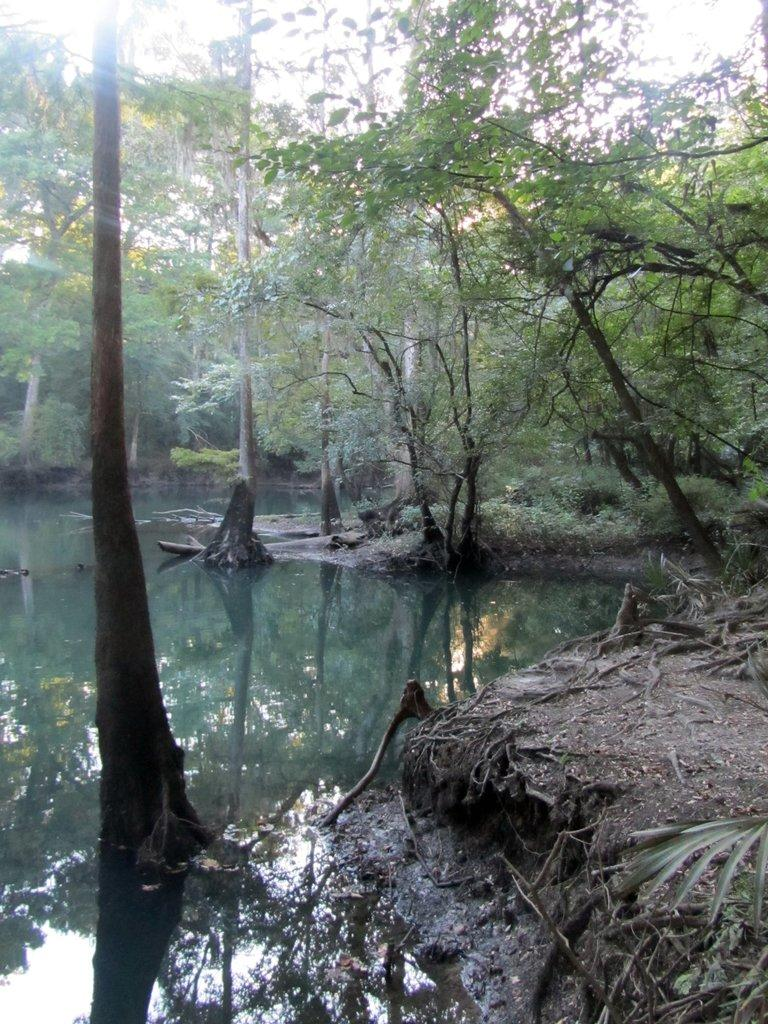Where was the image taken? The image is clicked outside the city. What can be seen in the foreground of the image? There is a ground visible in the foreground, and there is also a water body in the foreground. What is visible in the background of the image? The sky is visible in the background, and there are trees and plants in the background. What type of brain can be seen in the image? There is no brain present in the image; it features an outdoor scene with a ground, water body, sky, trees, and plants. 